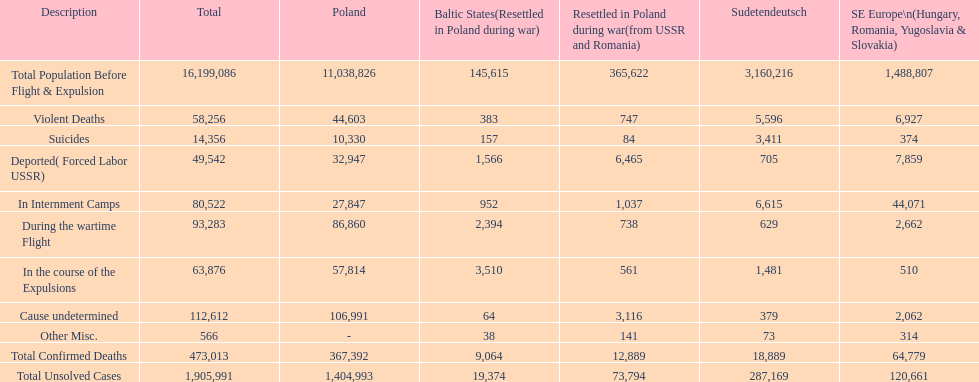Which country had the larger death tole? Poland. 